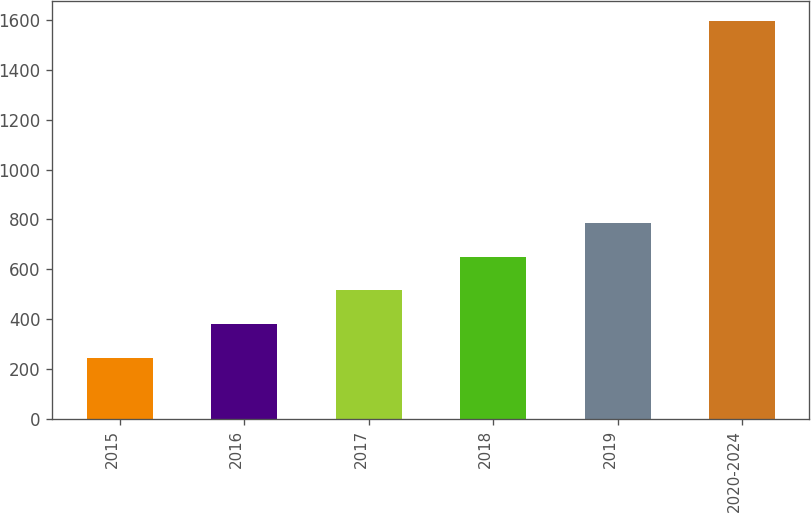Convert chart. <chart><loc_0><loc_0><loc_500><loc_500><bar_chart><fcel>2015<fcel>2016<fcel>2017<fcel>2018<fcel>2019<fcel>2020-2024<nl><fcel>244.6<fcel>379.8<fcel>515<fcel>650.2<fcel>785.4<fcel>1596.6<nl></chart> 